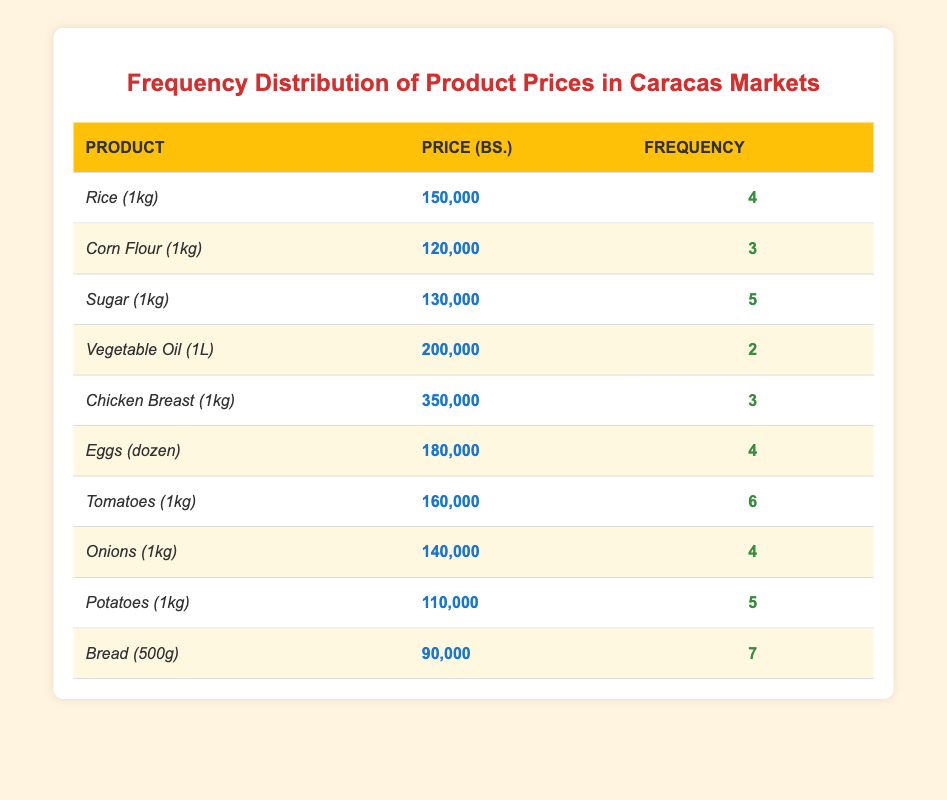What is the price of Rice (1kg)? The price for Rice (1kg) is listed directly in the table which states it as 150,000 Bs.
Answer: 150,000 Bs How many times does Sugar (1kg) appear in local markets? The frequency for Sugar (1kg) is noted in the table as 5 times, which indicates how often this product is available.
Answer: 5 times Which product has the highest frequency? By analyzing the frequency column, we see that Bread (500g) has a frequency of 7. This is greater than all other products listed.
Answer: Bread (500g) What is the total frequency of all products? Adding the frequencies together: 4 (Rice) + 3 (Corn Flour) + 5 (Sugar) + 2 (Vegetable Oil) + 3 (Chicken Breast) + 4 (Eggs) + 6 (Tomatoes) + 4 (Onions) + 5 (Potatoes) + 7 (Bread) = 43.
Answer: 43 Is the price of Chicken Breast (1kg) higher than Vegetable Oil (1L)? The price for Chicken Breast (1kg) is 350,000 Bs, while Vegetable Oil (1L) is 200,000 Bs. Since 350,000 > 200,000, the statement is true.
Answer: Yes What is the average price of the products listed? To find the average, we sum all prices: 150,000 + 120,000 + 130,000 + 200,000 + 350,000 + 180,000 + 160,000 + 140,000 + 110,000 + 90,000 = 1,620,000. Then, divide by the number of products (10): 1,620,000/10 = 162,000.
Answer: 162,000 Bs How many products have a price greater than 150,000 Bs.? By reviewing the price column, the products with prices greater than 150,000 Bs are Chicken Breast (350,000), Vegetable Oil (200,000), Eggs (180,000), Tomatoes (160,000). This counts to 4 products.
Answer: 4 products Does every product have a frequency of at least 2? Checking the frequency column reveals that the minimum frequency is 2 for Vegetable Oil, and all other products have a frequency equal to or greater than this. Therefore, the statement is true.
Answer: Yes What is the price difference between Meat (Chicken Breast) and staple (Rice)? The price for Chicken Breast (350,000) minus the price for Rice (150,000) is 350,000 - 150,000 = 200,000.
Answer: 200,000 Bs 